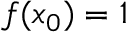Convert formula to latex. <formula><loc_0><loc_0><loc_500><loc_500>f ( x _ { 0 } ) = 1</formula> 